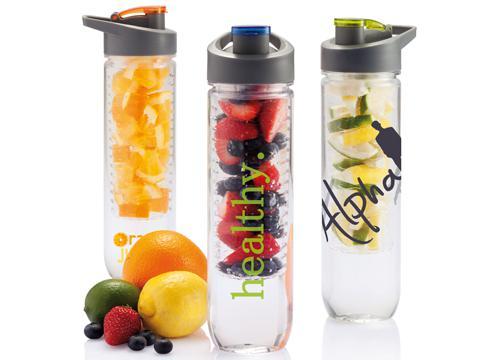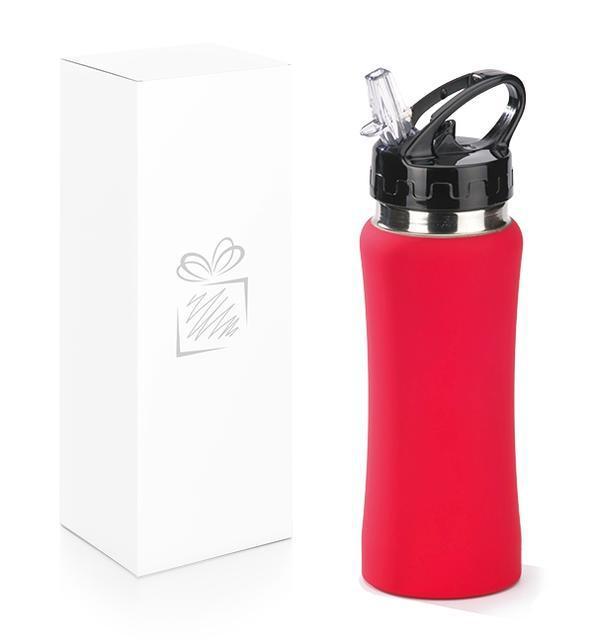The first image is the image on the left, the second image is the image on the right. For the images shown, is this caption "The combined images include a white upright box with a sketch of a gift box on it and a red water bottle." true? Answer yes or no. Yes. The first image is the image on the left, the second image is the image on the right. Assess this claim about the two images: "In at least one image there is a red bottle in front of a box with an engraved package on it.". Correct or not? Answer yes or no. Yes. 